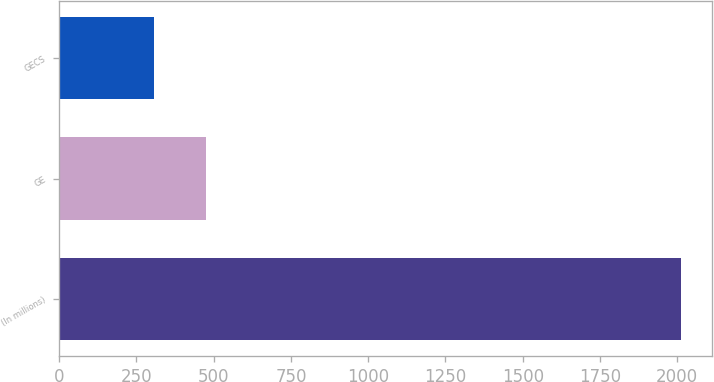Convert chart to OTSL. <chart><loc_0><loc_0><loc_500><loc_500><bar_chart><fcel>(In millions)<fcel>GE<fcel>GECS<nl><fcel>2013<fcel>476.7<fcel>306<nl></chart> 